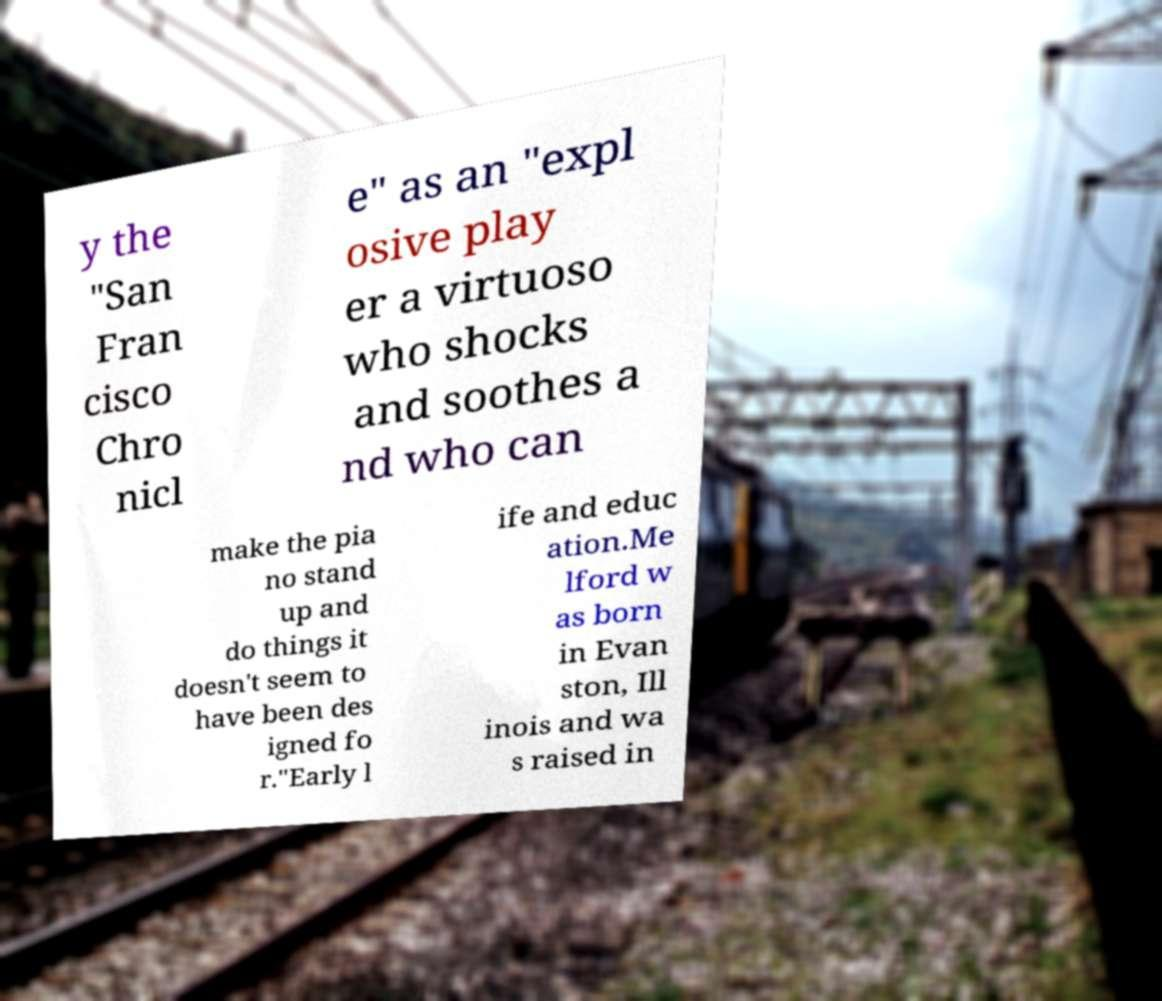What messages or text are displayed in this image? I need them in a readable, typed format. y the "San Fran cisco Chro nicl e" as an "expl osive play er a virtuoso who shocks and soothes a nd who can make the pia no stand up and do things it doesn't seem to have been des igned fo r."Early l ife and educ ation.Me lford w as born in Evan ston, Ill inois and wa s raised in 